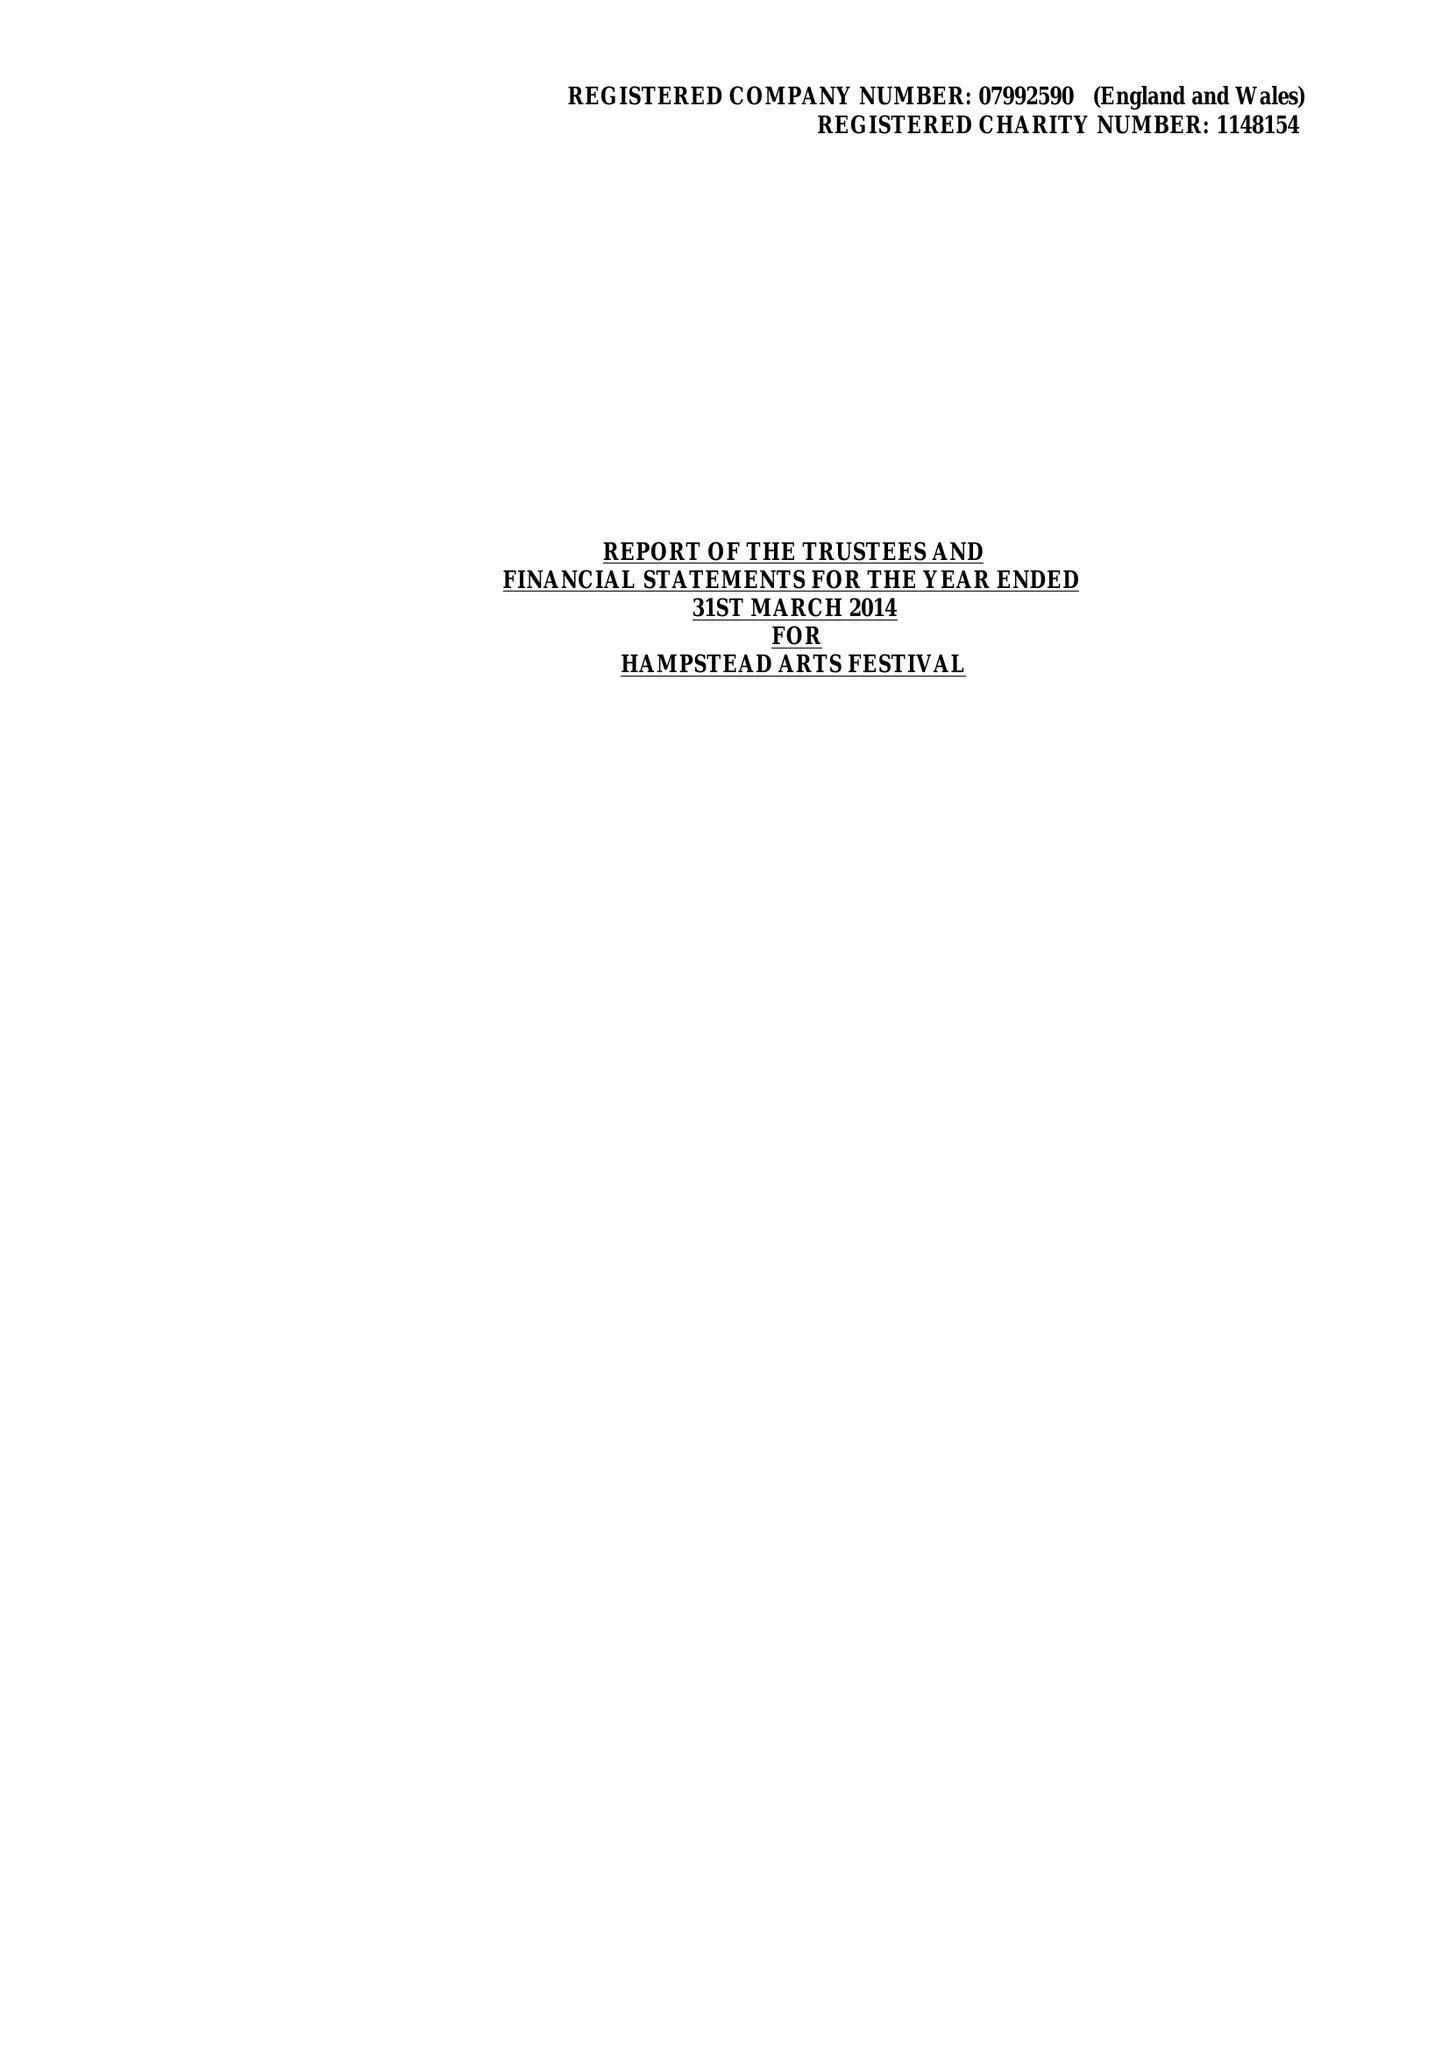What is the value for the address__post_town?
Answer the question using a single word or phrase. HARROW 